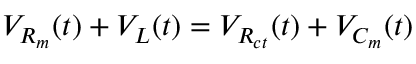<formula> <loc_0><loc_0><loc_500><loc_500>V _ { R _ { m } } ( t ) + V _ { L } ( t ) = V _ { R _ { c t } } ( t ) + V _ { C _ { m } } ( t )</formula> 